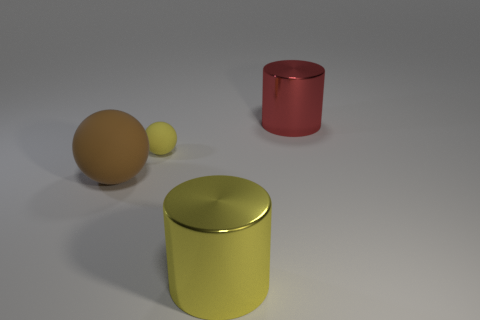Add 2 yellow objects. How many objects exist? 6 Subtract all yellow cylinders. Subtract all big yellow shiny things. How many objects are left? 2 Add 3 matte spheres. How many matte spheres are left? 5 Add 3 large yellow shiny cylinders. How many large yellow shiny cylinders exist? 4 Subtract 0 cyan balls. How many objects are left? 4 